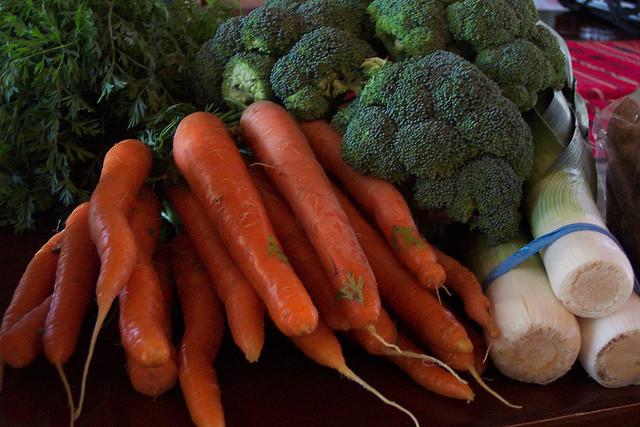What are the orange vegetables?
Be succinct. Carrots. Is this healthy?
Quick response, please. Yes. What is the vegetable on the left called?
Short answer required. Carrot. Has the produce been washed?
Give a very brief answer. No. Is this a salad?
Write a very short answer. No. How many veggies are there?
Answer briefly. 3. What are these food items?
Give a very brief answer. Vegetables. 